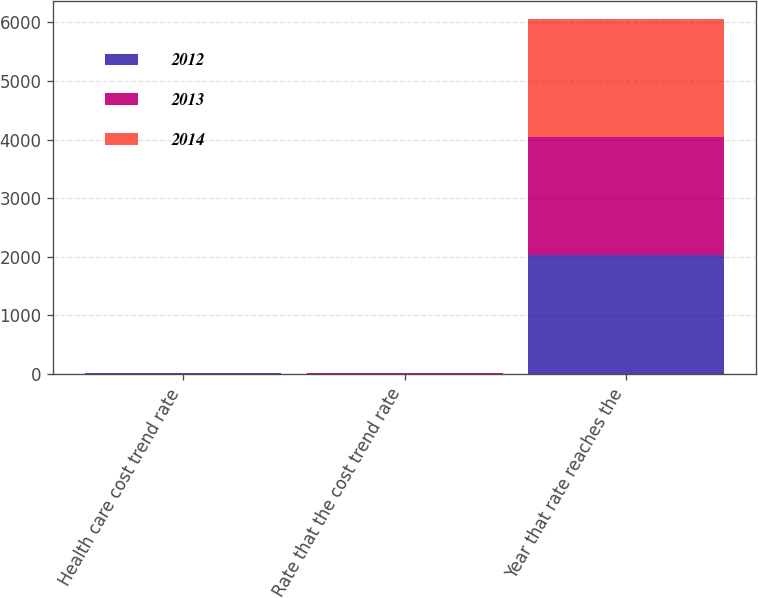Convert chart to OTSL. <chart><loc_0><loc_0><loc_500><loc_500><stacked_bar_chart><ecel><fcel>Health care cost trend rate<fcel>Rate that the cost trend rate<fcel>Year that rate reaches the<nl><fcel>2012<fcel>8<fcel>5<fcel>2025<nl><fcel>2013<fcel>7<fcel>5<fcel>2019<nl><fcel>2014<fcel>7<fcel>5<fcel>2019<nl></chart> 